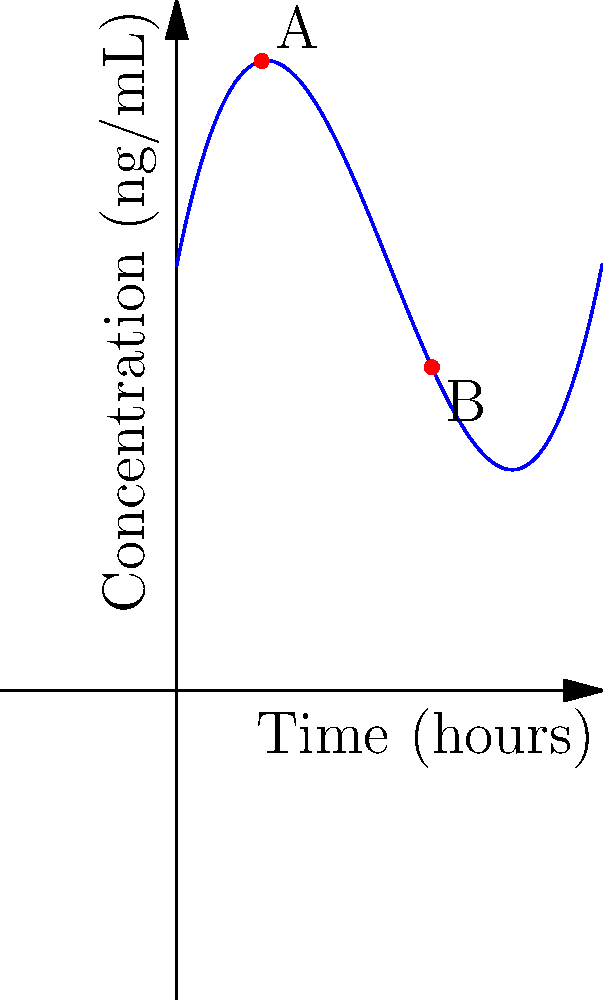A biomarker's concentration (in ng/mL) over time (in hours) is modeled by the cubic function $f(t) = 0.1t^3 - 1.5t^2 + 5t + 10$. Points A and B on the curve represent important clinical thresholds. What is the difference in biomarker concentration between points A and B? To solve this problem, we need to follow these steps:

1) Identify the time coordinates of points A and B:
   Point A is at t = 2 hours
   Point B is at t = 6 hours

2) Calculate the concentration at point A:
   $f(2) = 0.1(2)^3 - 1.5(2)^2 + 5(2) + 10$
   $= 0.1(8) - 1.5(4) + 10 + 10$
   $= 0.8 - 6 + 10 + 10$
   $= 14.8$ ng/mL

3) Calculate the concentration at point B:
   $f(6) = 0.1(6)^3 - 1.5(6)^2 + 5(6) + 10$
   $= 0.1(216) - 1.5(36) + 30 + 10$
   $= 21.6 - 54 + 30 + 10$
   $= 7.6$ ng/mL

4) Calculate the difference in concentration:
   Difference = Concentration at A - Concentration at B
   $= 14.8 - 7.6 = 7.2$ ng/mL
Answer: 7.2 ng/mL 